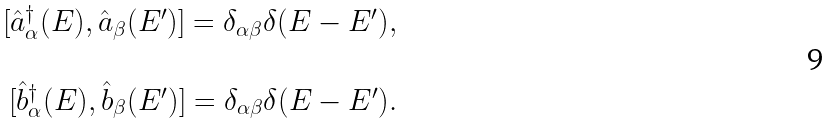Convert formula to latex. <formula><loc_0><loc_0><loc_500><loc_500>\begin{array} { c } [ \hat { a } ^ { \dagger } _ { \alpha } ( E ) , \hat { a } _ { \beta } ( E ^ { \prime } ) ] = \delta _ { \alpha \beta } \delta ( E - E ^ { \prime } ) , \\ \ \\ \ [ \hat { b } ^ { \dagger } _ { \alpha } ( E ) , \hat { b } _ { \beta } ( E ^ { \prime } ) ] = \delta _ { \alpha \beta } \delta ( E - E ^ { \prime } ) . \end{array}</formula> 